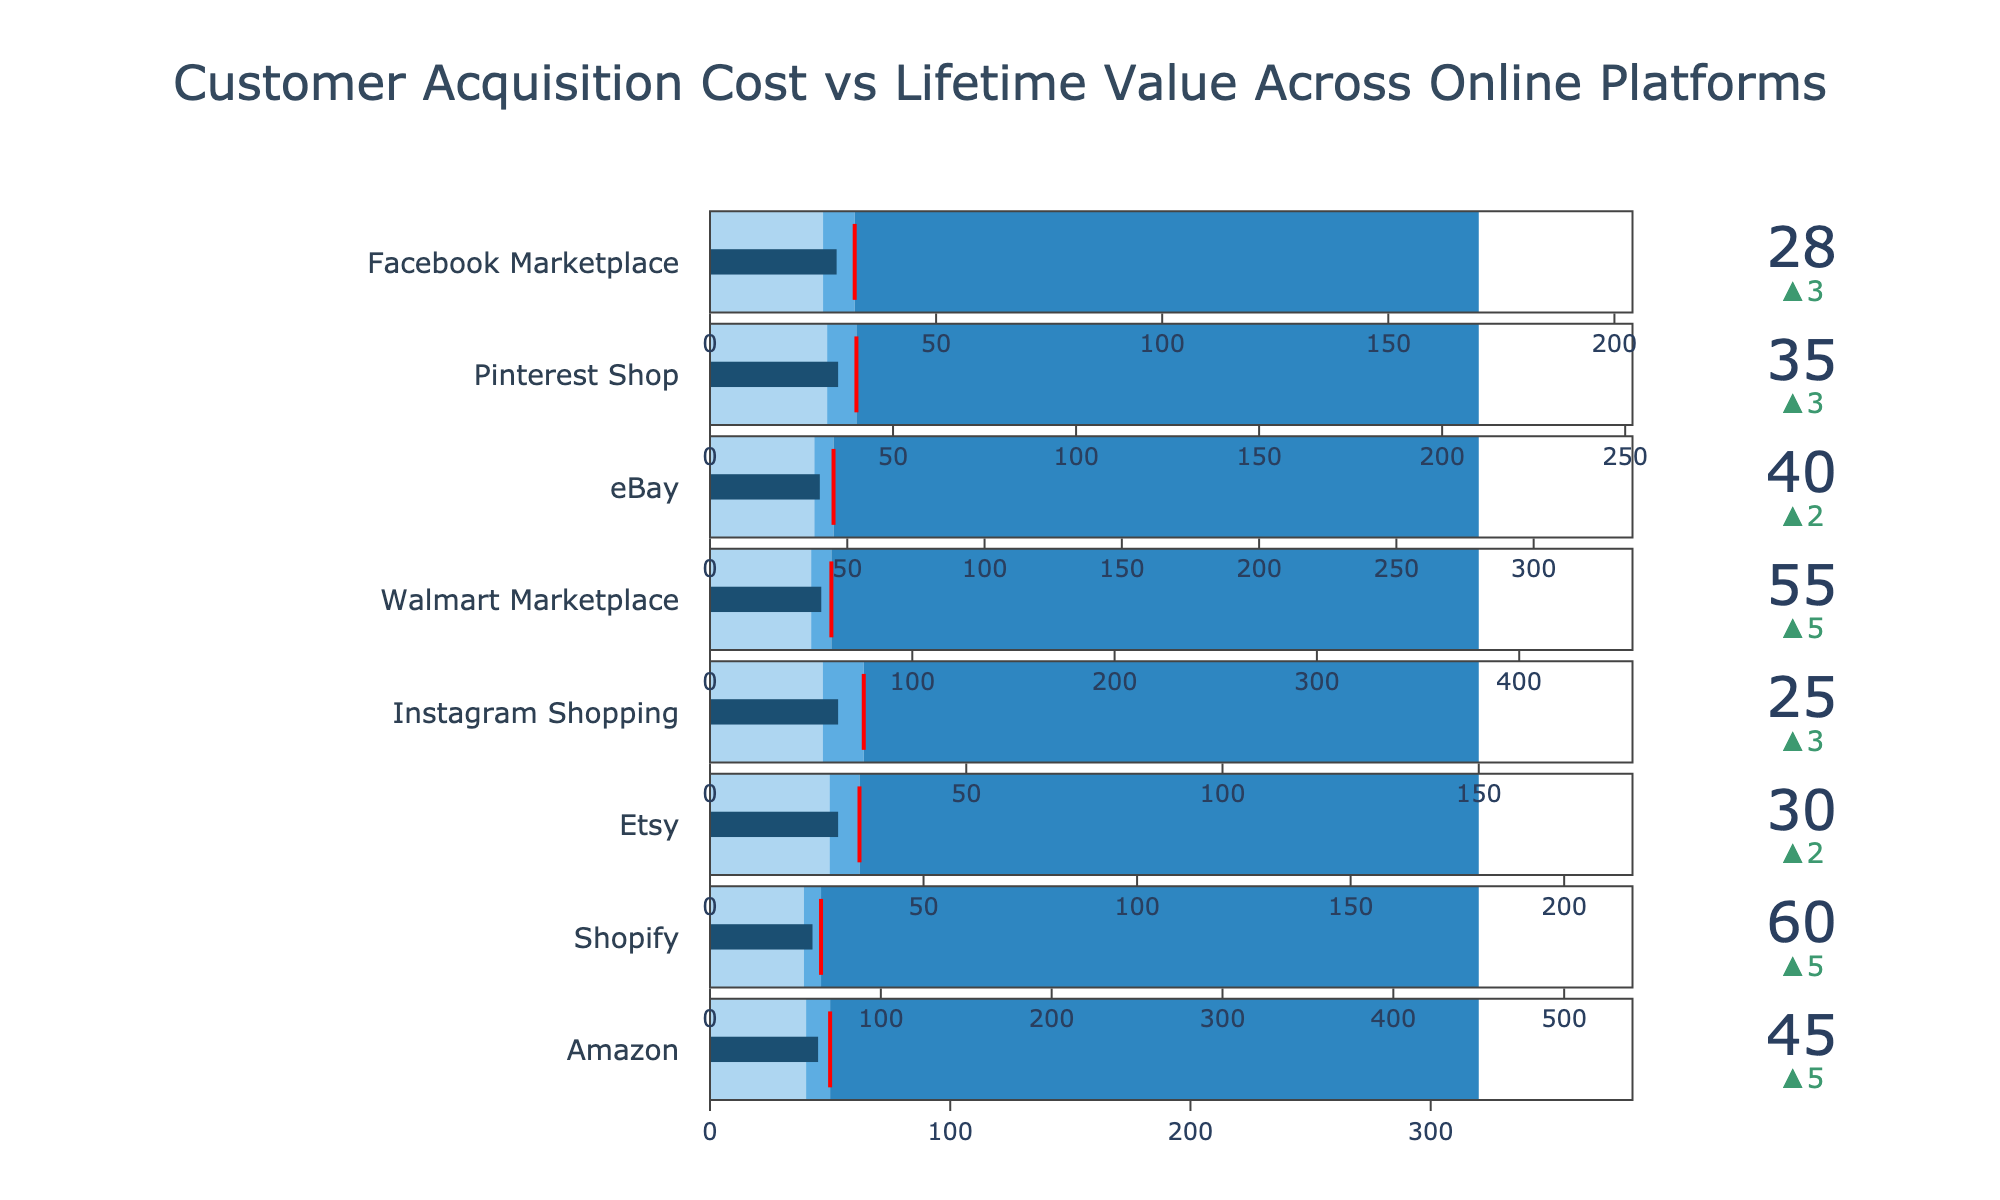What is the title of the chart? The title of the chart is displayed at the top and it says "Customer Acquisition Cost vs Lifetime Value Across Online Platforms".
Answer: Customer Acquisition Cost vs Lifetime Value Across Online Platforms Which platform has the lowest Customer Acquisition Cost (CAC)? By looking at the values presented for each platform, Instagram Shopping has the lowest CAC at 25.
Answer: Instagram Shopping What is the difference between the Industry Average CAC and the Target CAC for Shopify? The Industry Average CAC for Shopify is 65, and the Target CAC is 55, so the difference is 65 - 55 = 10.
Answer: 10 Which platform exceeds its Industry Average CAC the most? The value of Customer Acquisition Cost (CAC) should be compared to the Industry Average CAC for each platform, and the platform with the largest positive difference is Shopify with its CAC 60 exceeding the Industry Average of 65 by 5 units.
Answer: Shopify How does the Customer Acquisition Cost (CAC) for Facebook Marketplace compare to its Target CAC? Facebook Marketplace's CAC is 28, and its Target CAC is 25. Thus, 28 is 3 units above the Target CAC.
Answer: 3 units above Which platform has the highest Customer Lifetime Value (CLV)? By comparing the Customer Lifetime Values provided, Shopify has the highest CLV at 450.
Answer: Shopify What is the difference between the highest and lowest Customer Lifetime Value (CLV) across platforms? The highest CLV is for Shopify at 450 and the lowest CLV is for Instagram Shopping at 150. The difference is 450 - 150 = 300.
Answer: 300 Is the Customer Acquisition Cost (CAC) for Amazon above or below its Industry Average CAC? Amazon’s CAC is 45 and the Industry Average CAC is 50. Therefore, the CAC for Amazon is below its Industry Average CAC.
Answer: Below By how much does Etsy's Customer Acquisition Cost (CAC) exceed its Target CAC? Etsy's CAC is 30, and its Target CAC is 28, so Etsy's CAC exceeds its Target CAC by 30 - 28 = 2.
Answer: 2 What is the median Customer Acquisition Cost (CAC) among all platforms listed? To find the median, list all CAC values in ascending order: 25, 28, 30, 35, 40, 45, 55, 60. With 8 data points, the median is the average of the 4th and 5th values (35 + 40) / 2 = 37.5.
Answer: 37.5 